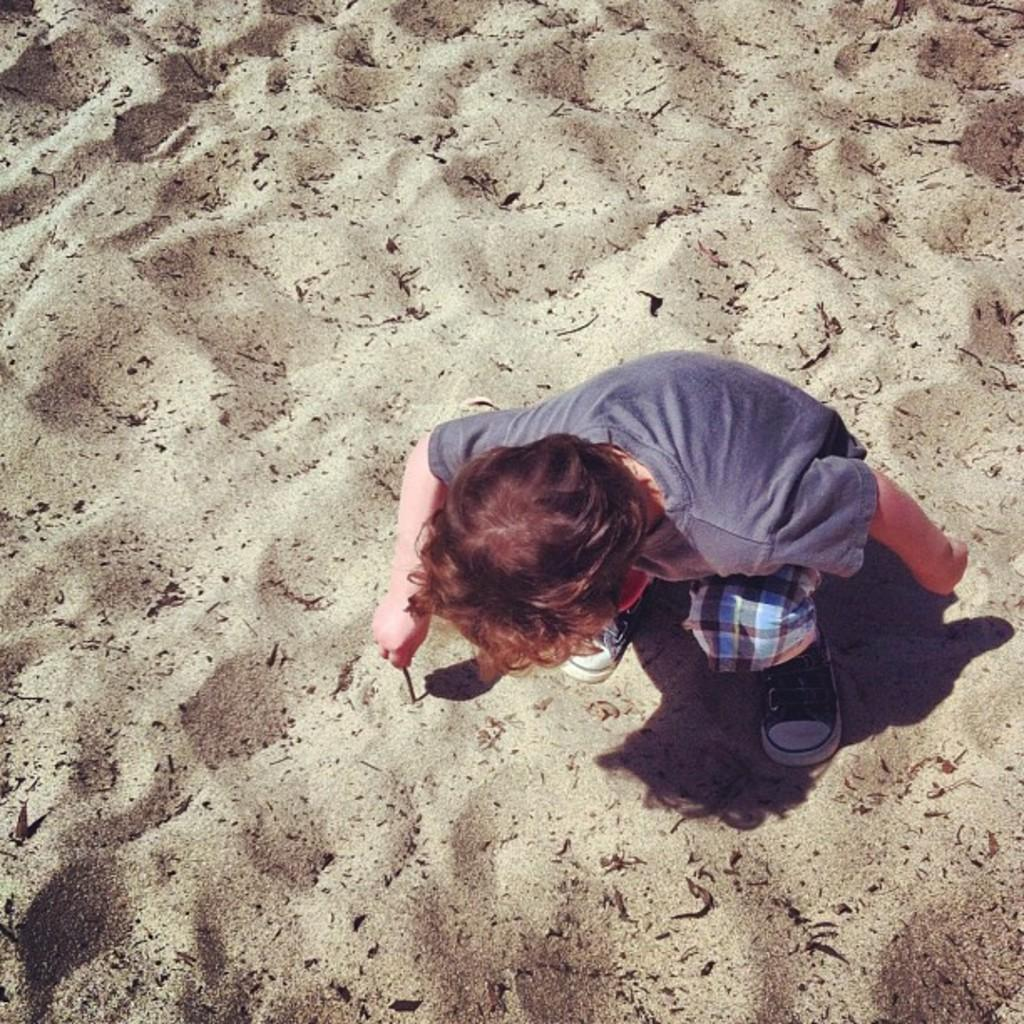Who is the main subject in the image? There is a boy in the image. What is the boy wearing? The boy is wearing a T-shirt, pants, and shoes. What is the boy holding in his hand? The boy is holding a wooden stick in his hand. What type of terrain is visible in the image? There is sand visible in the image. What type of leaf is the maid holding in the image? There is no maid or leaf present in the image. Is the boy swimming in the sand in the image? The boy is not swimming in the sand; he is standing on it while holding a wooden stick. 